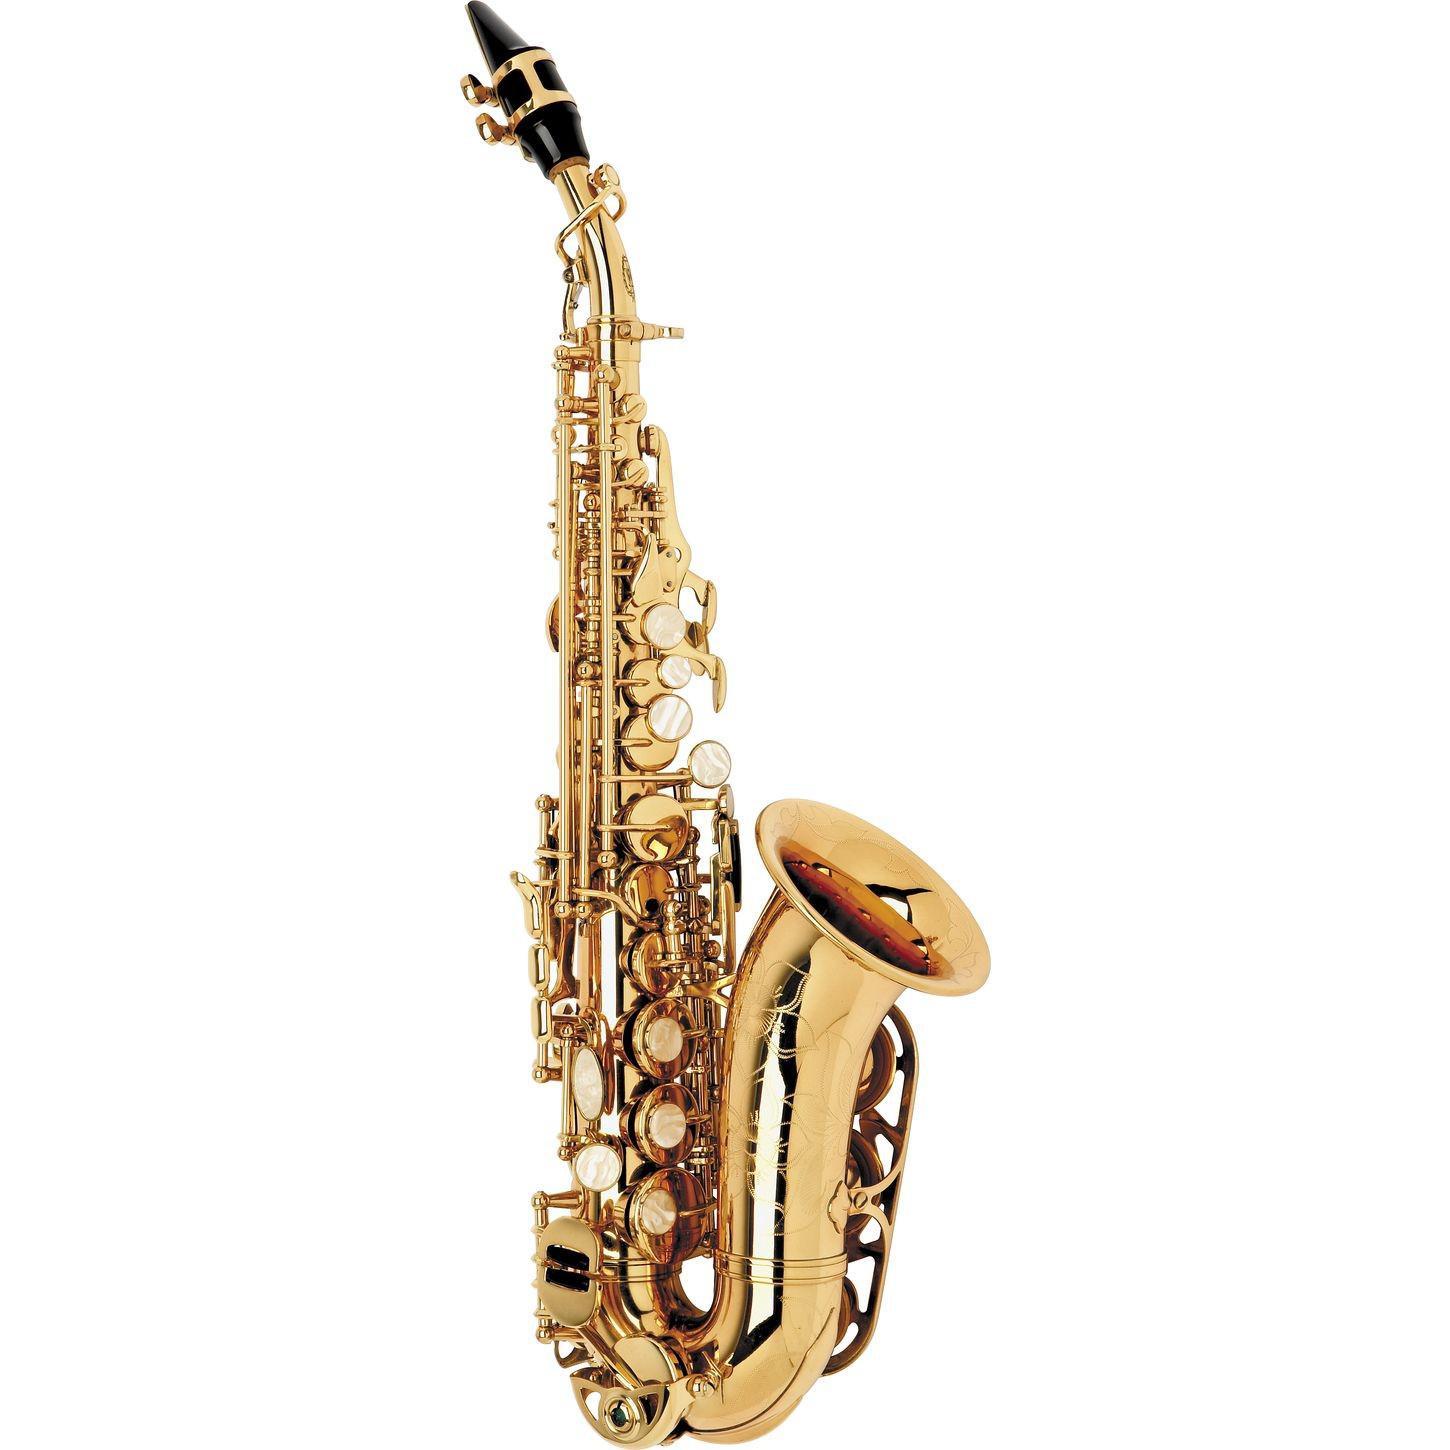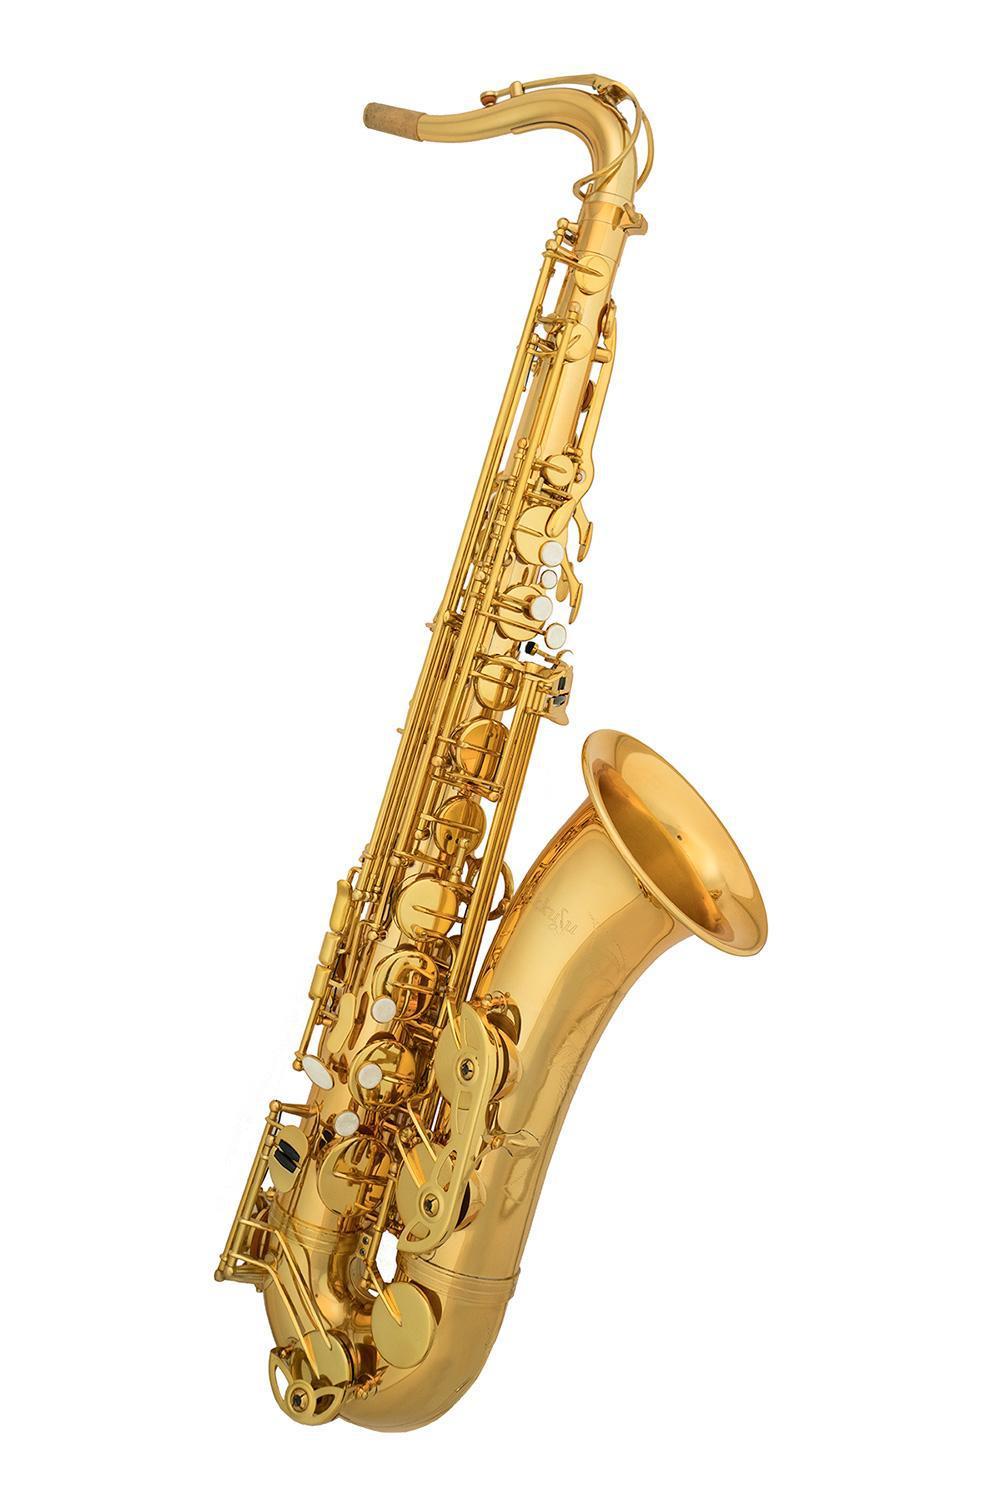The first image is the image on the left, the second image is the image on the right. For the images shown, is this caption "The saxophone on the left has a black mouthpiece and is displayed vertically, while the saxophone on the right has no dark mouthpiece and is tilted to the right." true? Answer yes or no. Yes. 